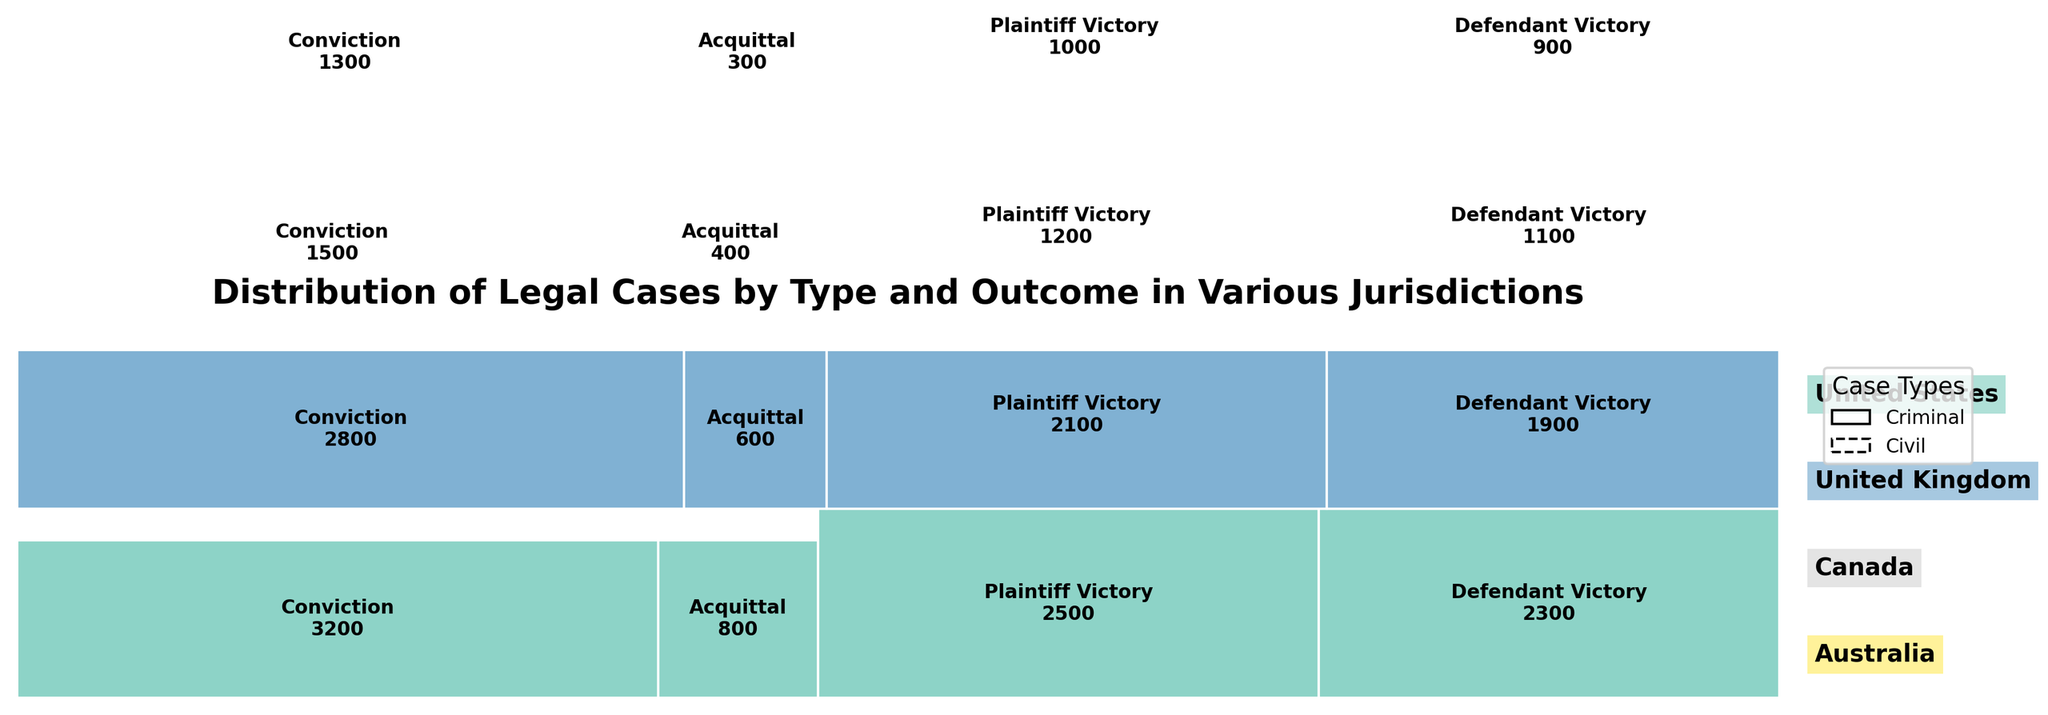What's the title of the figure? The title is usually displayed prominently at the top of the figure, often in larger or bold font. This figure's title is at the top center.
Answer: Distribution of Legal Cases by Type and Outcome in Various Jurisdictions Which jurisdiction has the highest number of criminal case convictions? Looking at the mosaic plot, you will see that different jurisdictions have different sizes of sections for criminal case convictions. The largest section corresponds to the United States.
Answer: United States How many jurisdictions are represented in the plot? The plot segments are color-coded and labeled along the right-hand side, listing all the jurisdictions involved. Count the unique labels.
Answer: Four Which case type has more acquittals in Canada, criminal or civil cases? Look at the sections corresponding to Canada. Compare the sizes of the sections for criminal acquittals and any for civil cases (although civil cases do not typically have acquittals, focus on the relevant part).
Answer: Criminal Compare the total number of civil plaintiff victories in the United States and Canada. Which jurisdiction has more? Look at the sections for civil plaintiff victories for both the United States and Canada. The section for the United States is visibly larger.
Answer: United States Which outcome has the least representation in Australia across both types of cases? Find the smallest section related to Australia. It’s the one corresponding to the criminal acquittal outcome.
Answer: Criminal Acquittal How does the number of civil defendant victories in the United Kingdom compare to that in Canada? Look for the sections representing civil defendant victories in both jurisdictions and compare sizes. The United Kingdom's section is larger than Canada's.
Answer: United Kingdom What is the total count of criminal acquittals across all jurisdictions? Sum the individual counts of criminal acquittals from all jurisdictions: United States (800), United Kingdom (600), Canada (400), Australia (300). The total is 800 + 600 + 400 + 300.
Answer: 2100 Are criminal convictions greater than civil plaintiff victories in Canada? Compare the sizes of the sections for criminal convictions and civil plaintiff victories in Canada. The criminal convictions section is larger (1500) than the civil plaintiff victories section (1200).
Answer: Yes Which jurisdiction represents the smallest proportion of total cases, and what might this suggest? By observing the entire mosaic plot, note that Australia has the smallest total combined area of sections, indicating fewer total cases.
Answer: Australia 